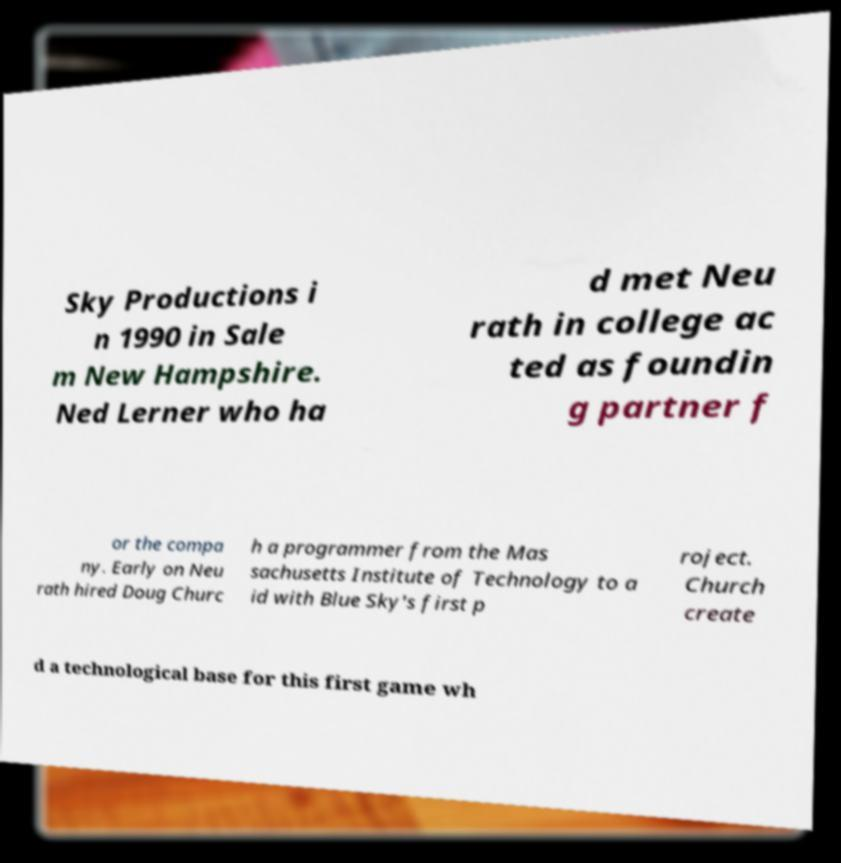Could you extract and type out the text from this image? Sky Productions i n 1990 in Sale m New Hampshire. Ned Lerner who ha d met Neu rath in college ac ted as foundin g partner f or the compa ny. Early on Neu rath hired Doug Churc h a programmer from the Mas sachusetts Institute of Technology to a id with Blue Sky's first p roject. Church create d a technological base for this first game wh 